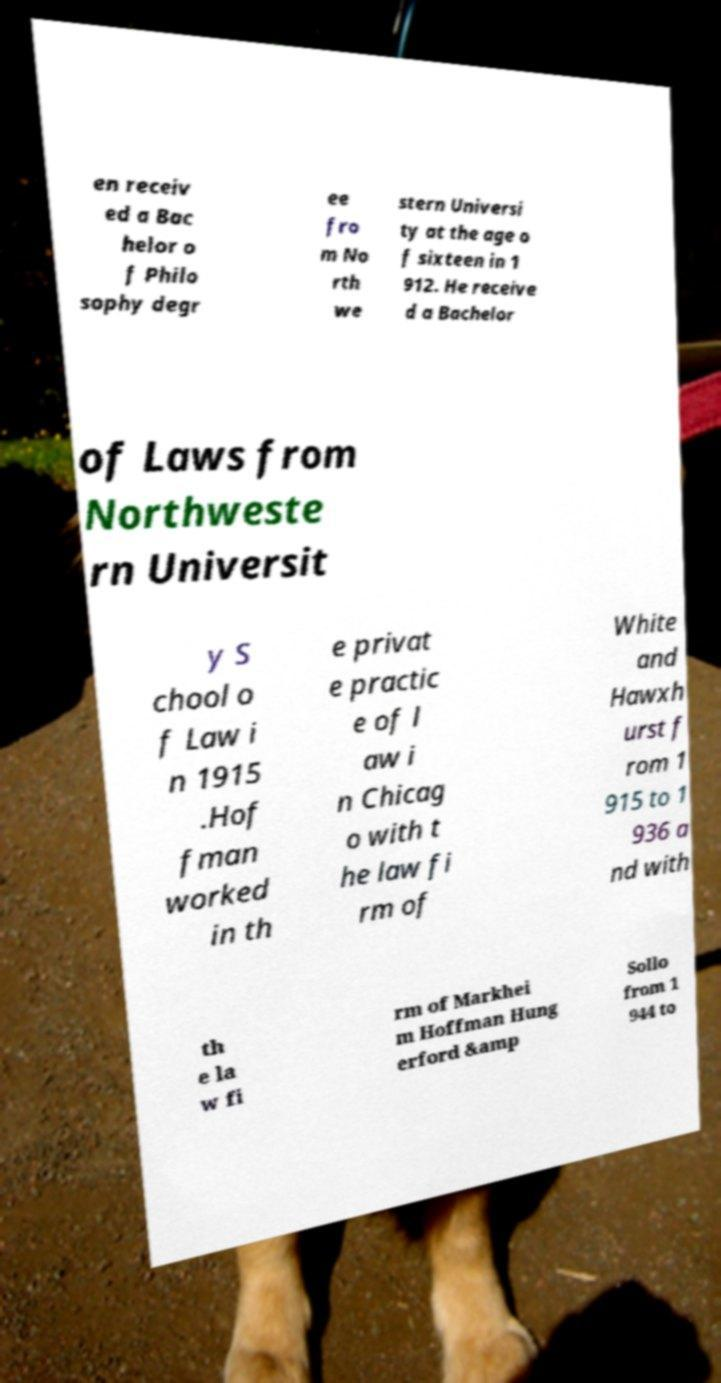Could you extract and type out the text from this image? en receiv ed a Bac helor o f Philo sophy degr ee fro m No rth we stern Universi ty at the age o f sixteen in 1 912. He receive d a Bachelor of Laws from Northweste rn Universit y S chool o f Law i n 1915 .Hof fman worked in th e privat e practic e of l aw i n Chicag o with t he law fi rm of White and Hawxh urst f rom 1 915 to 1 936 a nd with th e la w fi rm of Markhei m Hoffman Hung erford &amp Sollo from 1 944 to 